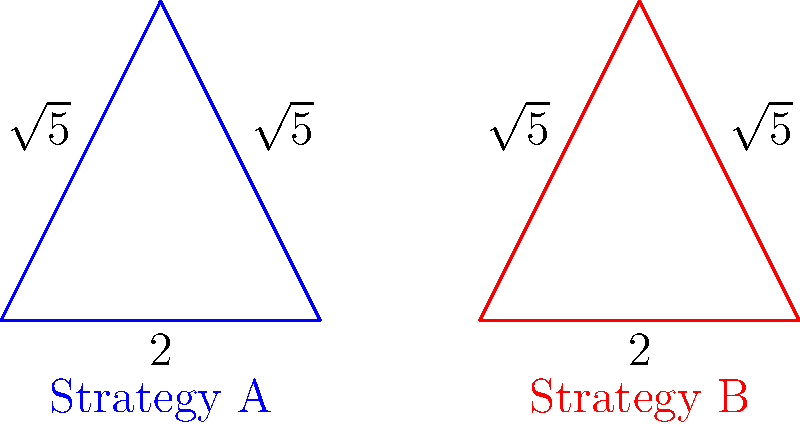As a parole officer, you're evaluating two intervention strategies represented by the triangles above. If these shapes are congruent, what theorem would you use to prove their congruence, and how does this relate to the effectiveness of the strategies? To determine if the triangles representing Strategy A and Strategy B are congruent, we need to follow these steps:

1. Observe the given information:
   - Both triangles have a base of length 2.
   - Both triangles have two sides of length $\sqrt{5}$.

2. Identify the theorem:
   The Side-Side-Side (SSS) Congruence Theorem states that if three sides of one triangle are congruent to three sides of another triangle, then the triangles are congruent.

3. Apply the theorem:
   - The base sides are equal (2 units each).
   - The other two sides of each triangle are equal ($\sqrt{5}$ units each).
   - Therefore, all three sides of both triangles are equal.

4. Conclusion:
   The triangles are congruent by the SSS Congruence Theorem.

5. Relating to intervention strategies:
   The congruence of these triangles suggests that both intervention strategies have similar characteristics or "dimensions" of effectiveness. As a parole officer, this could indicate that both strategies are equally balanced in terms of their approach and potential outcomes, despite possibly different methods.
Answer: SSS Congruence Theorem; equal effectiveness potential 